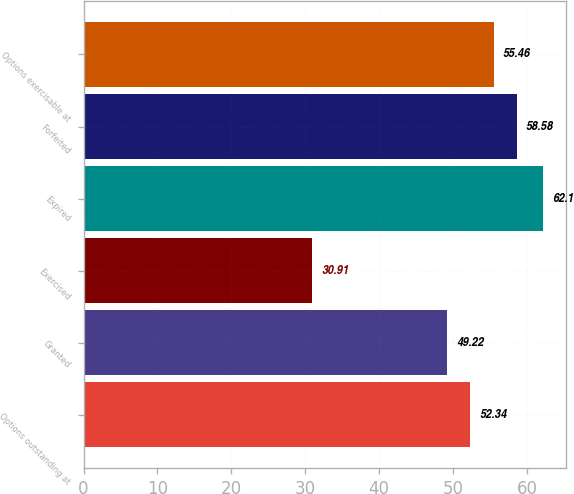<chart> <loc_0><loc_0><loc_500><loc_500><bar_chart><fcel>Options outstanding at<fcel>Granted<fcel>Exercised<fcel>Expired<fcel>Forfeited<fcel>Options exercisable at<nl><fcel>52.34<fcel>49.22<fcel>30.91<fcel>62.1<fcel>58.58<fcel>55.46<nl></chart> 